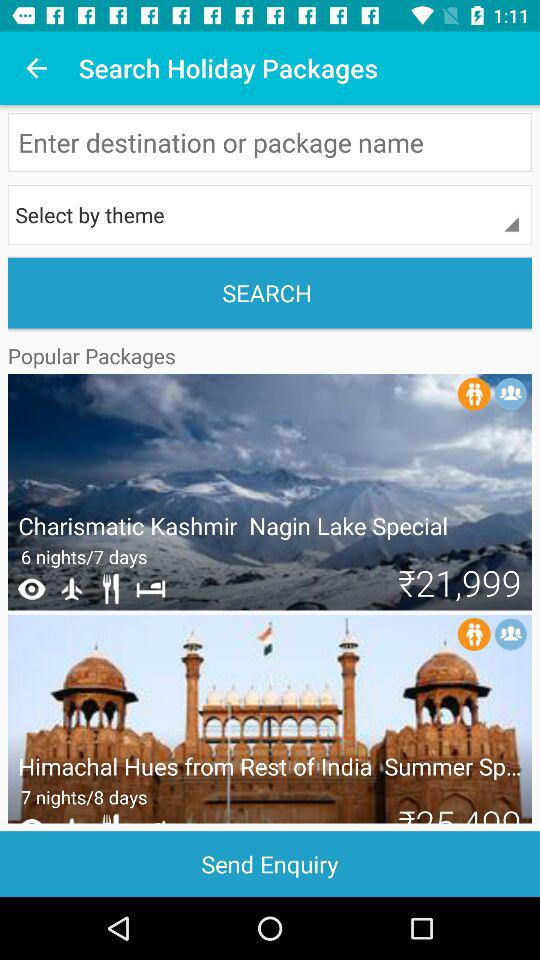The trip is planned for how many days?
When the provided information is insufficient, respond with <no answer>. <no answer> 